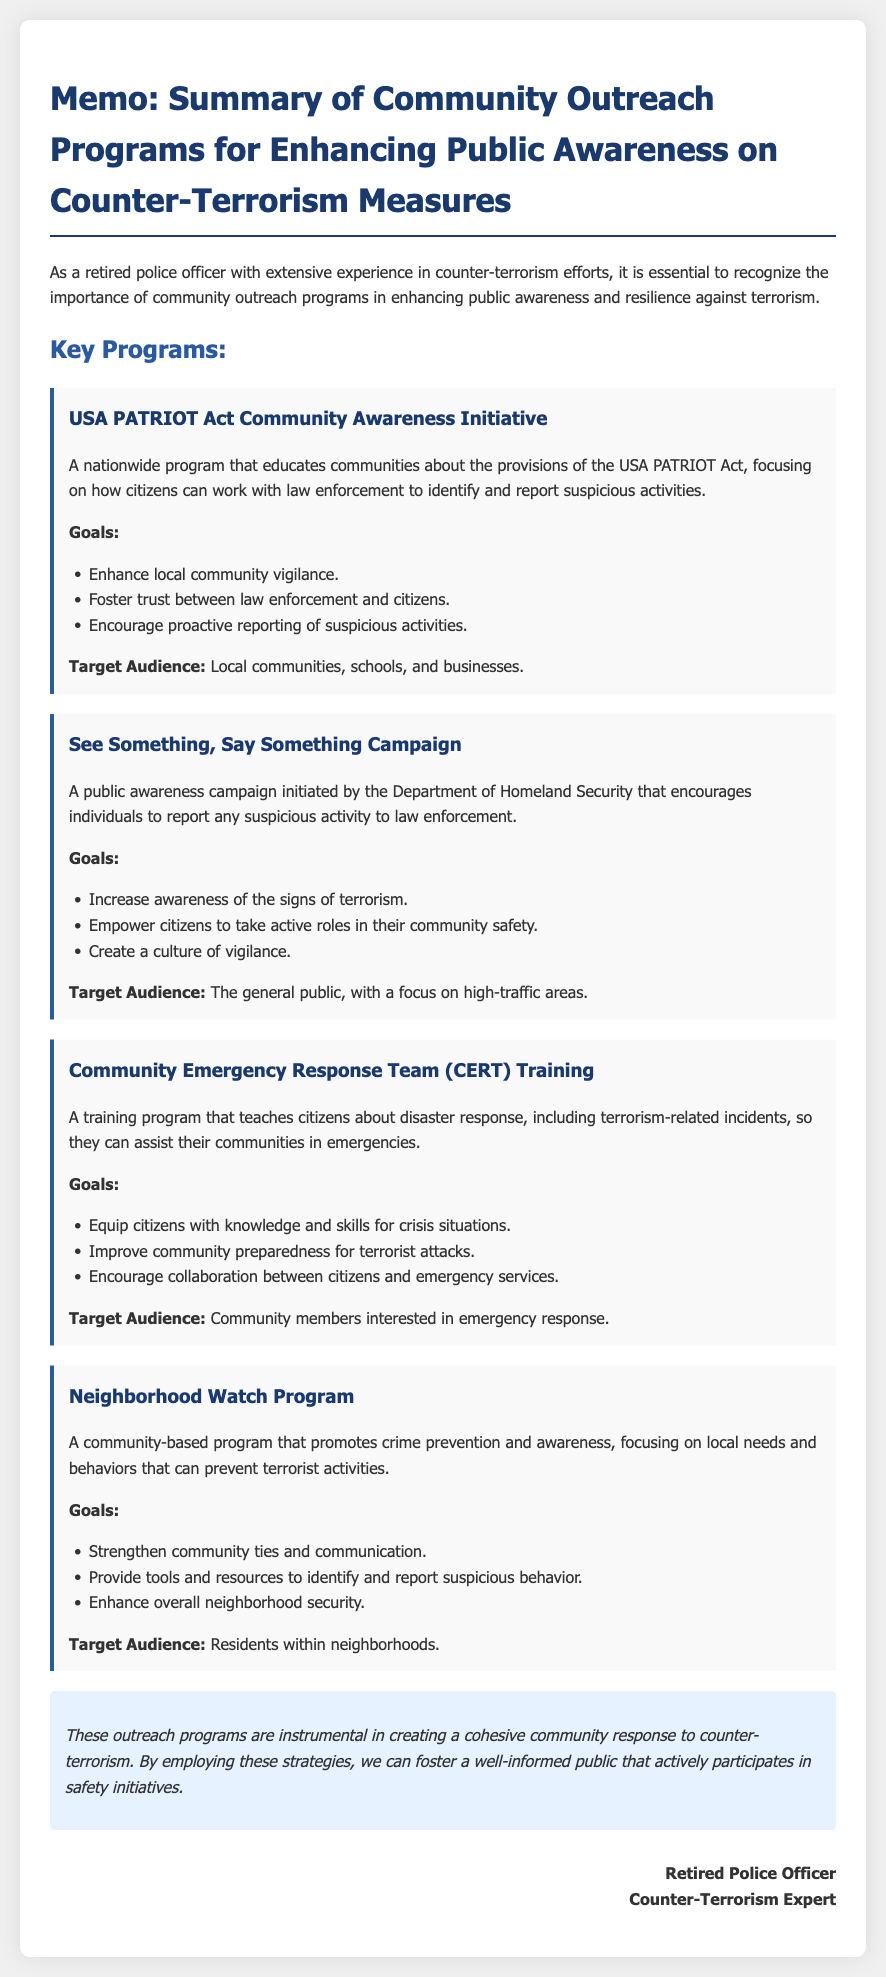What is the first program mentioned in the memo? The first program is titled as "USA PATRIOT Act Community Awareness Initiative."
Answer: USA PATRIOT Act Community Awareness Initiative What is one goal of the "See Something, Say Something Campaign"? One goal of this campaign is to "Increase awareness of the signs of terrorism."
Answer: Increase awareness of the signs of terrorism Who initiated the "See Something, Say Something Campaign"? The campaign was initiated by the "Department of Homeland Security."
Answer: Department of Homeland Security What is the target audience for the Community Emergency Response Team (CERT) Training? The target audience for the CERT training is "Community members interested in emergency response."
Answer: Community members interested in emergency response What is a key focus of the Neighborhood Watch Program? A key focus of the Neighborhood Watch Program is on "local needs and behaviors that can prevent terrorist activities."
Answer: local needs and behaviors that can prevent terrorist activities What type of document is this? This is a memo summarizing community outreach programs related to counter-terrorism measures.
Answer: memo What is the conclusion of the document about outreach programs? The conclusion states that these programs are "instrumental in creating a cohesive community response to counter-terrorism."
Answer: instrumental in creating a cohesive community response to counter-terrorism How many programs are outlined in the memo? Four programs are outlined in the memo.
Answer: Four 